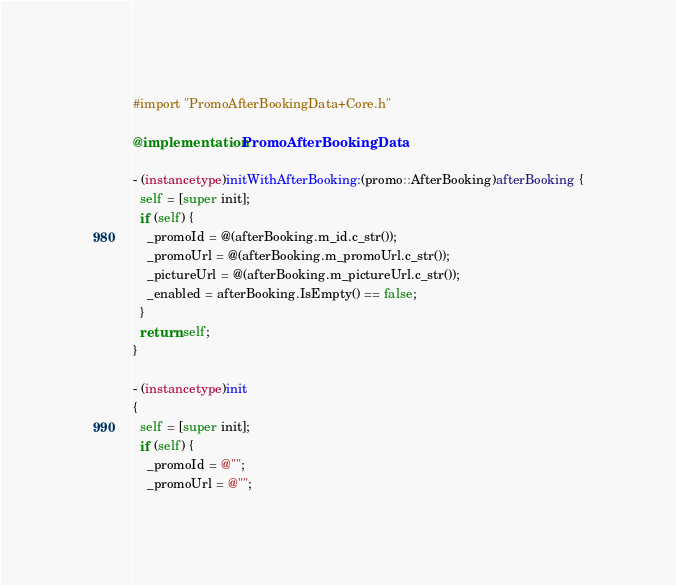<code> <loc_0><loc_0><loc_500><loc_500><_ObjectiveC_>#import "PromoAfterBookingData+Core.h"

@implementation PromoAfterBookingData

- (instancetype)initWithAfterBooking:(promo::AfterBooking)afterBooking {
  self = [super init];
  if (self) {
    _promoId = @(afterBooking.m_id.c_str());
    _promoUrl = @(afterBooking.m_promoUrl.c_str());
    _pictureUrl = @(afterBooking.m_pictureUrl.c_str());
    _enabled = afterBooking.IsEmpty() == false;
  }
  return self;
}

- (instancetype)init
{
  self = [super init];
  if (self) {
    _promoId = @"";
    _promoUrl = @"";</code> 